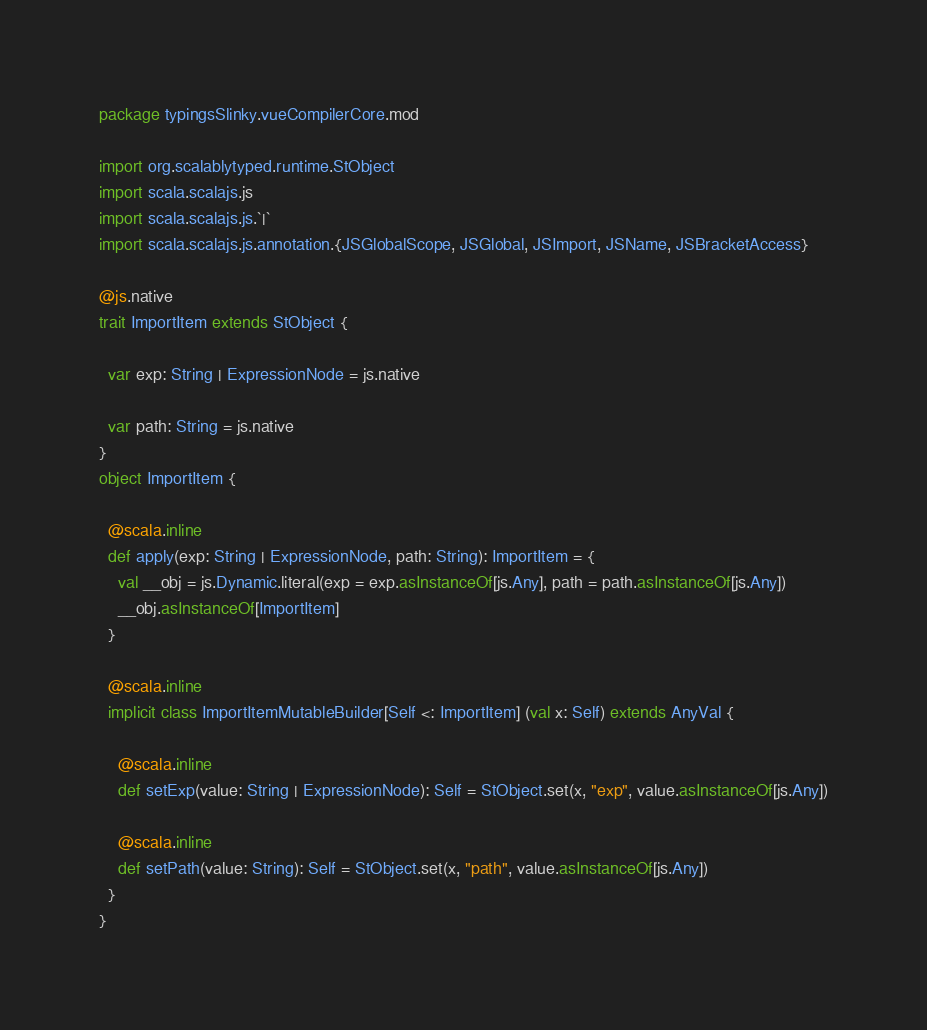Convert code to text. <code><loc_0><loc_0><loc_500><loc_500><_Scala_>package typingsSlinky.vueCompilerCore.mod

import org.scalablytyped.runtime.StObject
import scala.scalajs.js
import scala.scalajs.js.`|`
import scala.scalajs.js.annotation.{JSGlobalScope, JSGlobal, JSImport, JSName, JSBracketAccess}

@js.native
trait ImportItem extends StObject {
  
  var exp: String | ExpressionNode = js.native
  
  var path: String = js.native
}
object ImportItem {
  
  @scala.inline
  def apply(exp: String | ExpressionNode, path: String): ImportItem = {
    val __obj = js.Dynamic.literal(exp = exp.asInstanceOf[js.Any], path = path.asInstanceOf[js.Any])
    __obj.asInstanceOf[ImportItem]
  }
  
  @scala.inline
  implicit class ImportItemMutableBuilder[Self <: ImportItem] (val x: Self) extends AnyVal {
    
    @scala.inline
    def setExp(value: String | ExpressionNode): Self = StObject.set(x, "exp", value.asInstanceOf[js.Any])
    
    @scala.inline
    def setPath(value: String): Self = StObject.set(x, "path", value.asInstanceOf[js.Any])
  }
}
</code> 